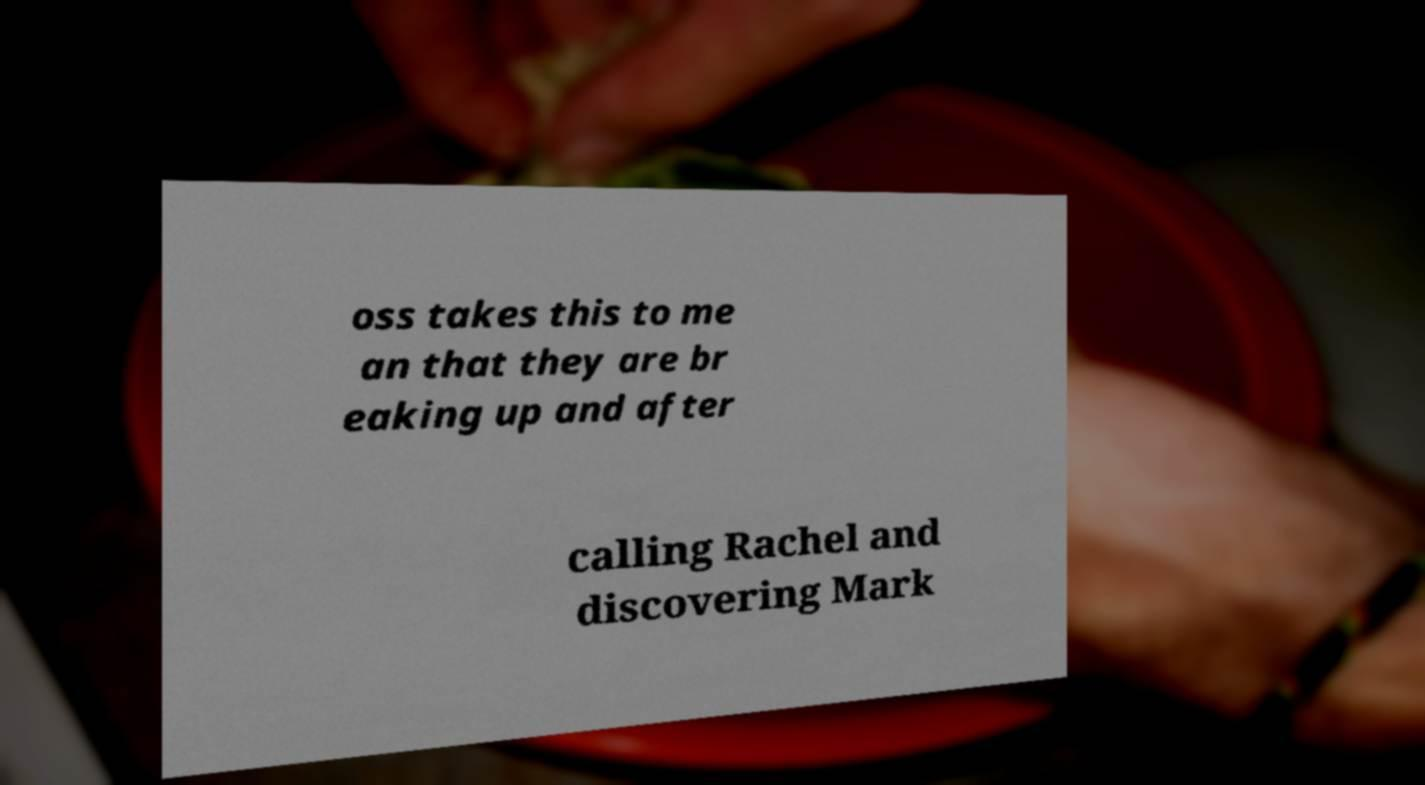Can you read and provide the text displayed in the image?This photo seems to have some interesting text. Can you extract and type it out for me? oss takes this to me an that they are br eaking up and after calling Rachel and discovering Mark 